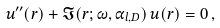Convert formula to latex. <formula><loc_0><loc_0><loc_500><loc_500>u ^ { \prime \prime } ( r ) + \mathfrak { I } ( r ; \omega , \alpha _ { l , D } ) \, u ( r ) = 0 \, ,</formula> 